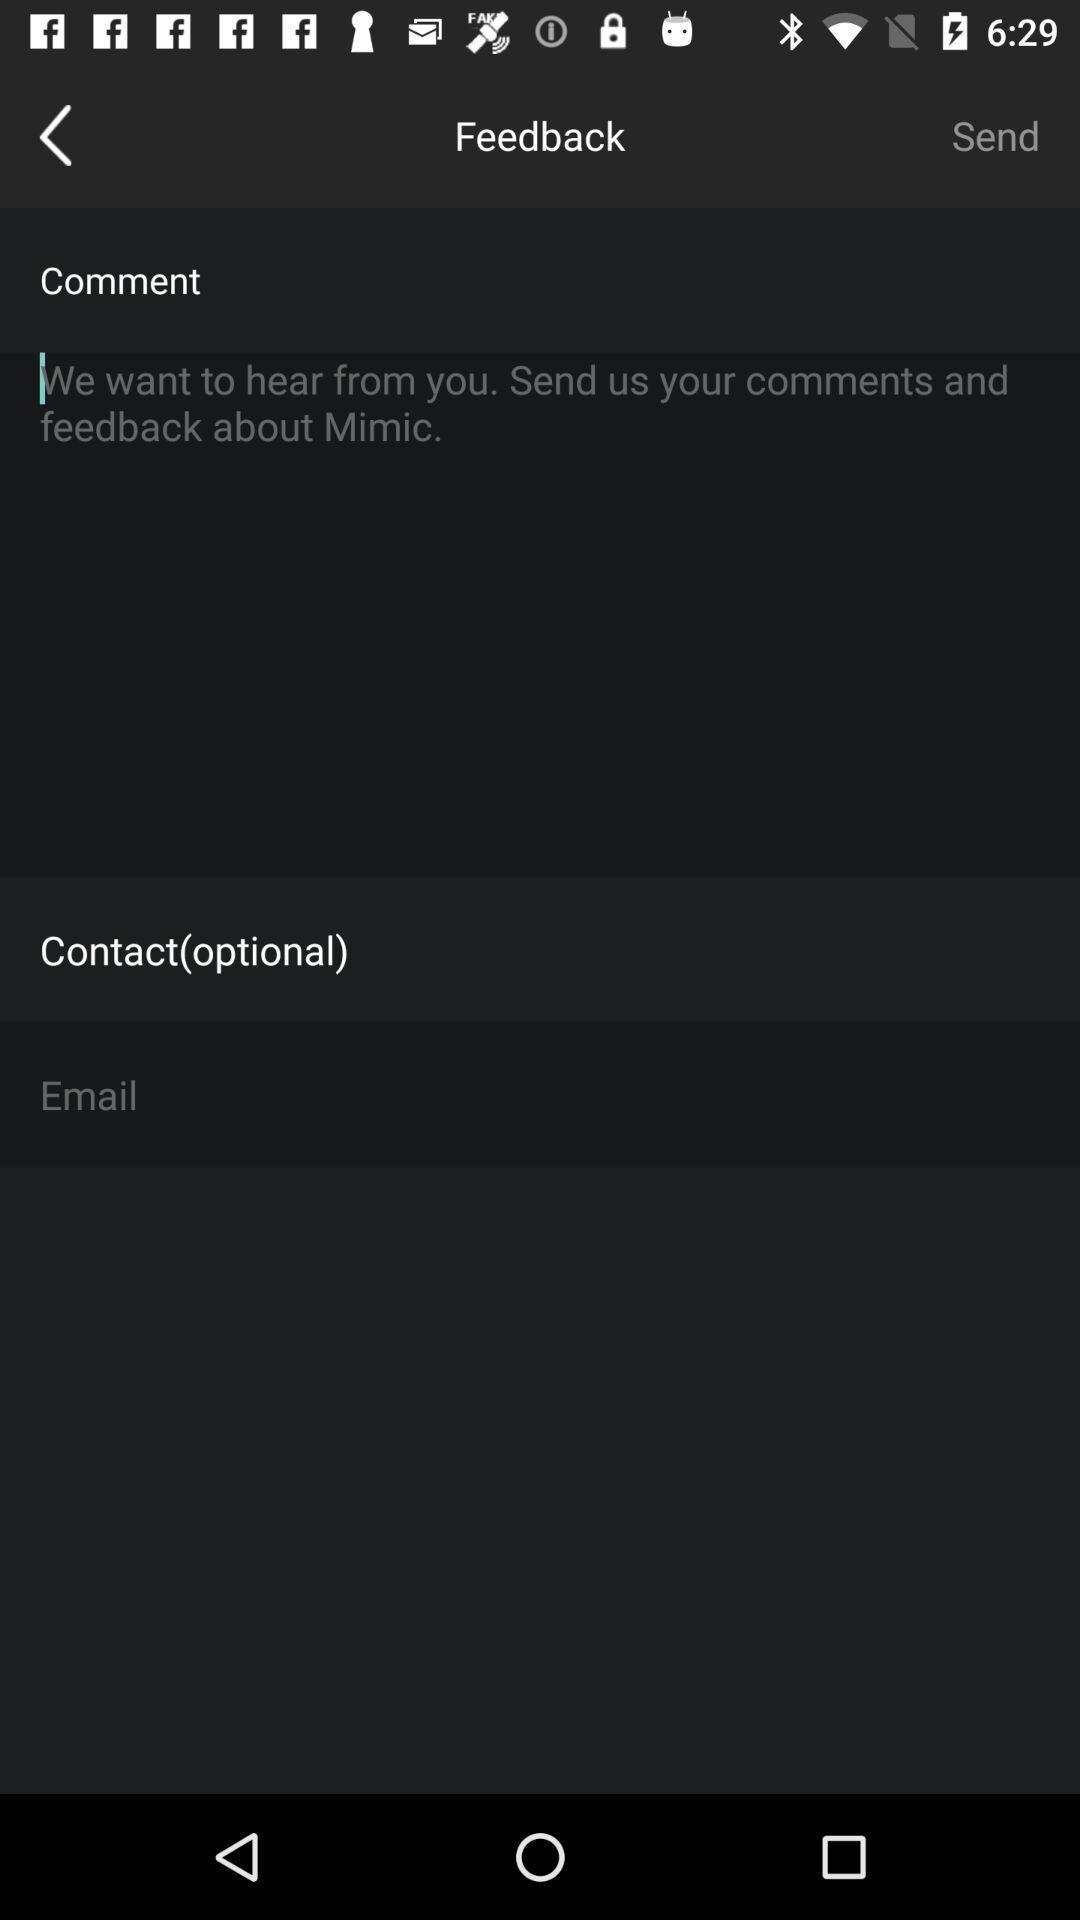Explain what's happening in this screen capture. Screen showing feedback page. 